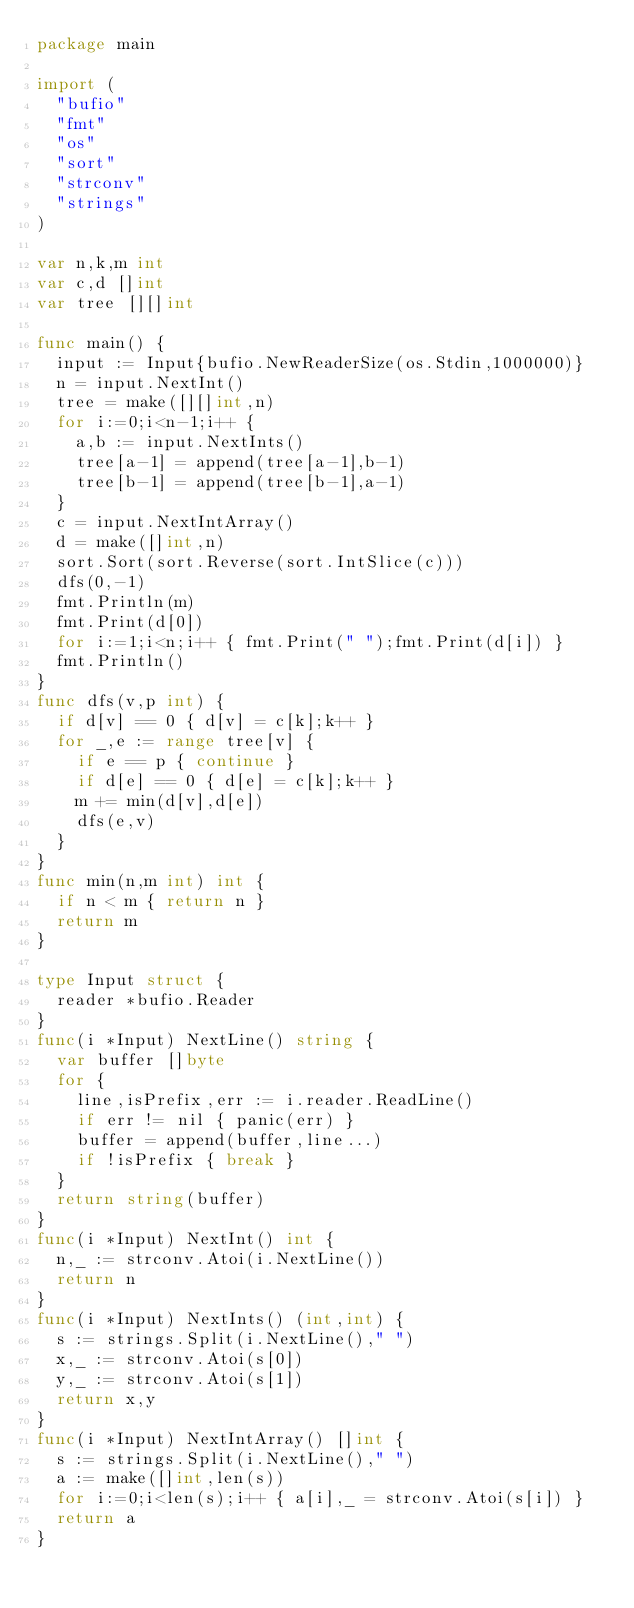<code> <loc_0><loc_0><loc_500><loc_500><_Go_>package main

import (
  "bufio"
  "fmt"
  "os"
  "sort"
  "strconv"
  "strings"
)

var n,k,m int
var c,d []int
var tree [][]int

func main() {
  input := Input{bufio.NewReaderSize(os.Stdin,1000000)}
  n = input.NextInt()
  tree = make([][]int,n)
  for i:=0;i<n-1;i++ {
    a,b := input.NextInts()
    tree[a-1] = append(tree[a-1],b-1)
    tree[b-1] = append(tree[b-1],a-1)
  }
  c = input.NextIntArray()
  d = make([]int,n)
  sort.Sort(sort.Reverse(sort.IntSlice(c)))
  dfs(0,-1)
  fmt.Println(m)
  fmt.Print(d[0])
  for i:=1;i<n;i++ { fmt.Print(" ");fmt.Print(d[i]) }
  fmt.Println()
}
func dfs(v,p int) {
  if d[v] == 0 { d[v] = c[k];k++ }
  for _,e := range tree[v] {
    if e == p { continue }
    if d[e] == 0 { d[e] = c[k];k++ }
    m += min(d[v],d[e])
    dfs(e,v)
  }
}
func min(n,m int) int {
  if n < m { return n }
  return m
}

type Input struct {
  reader *bufio.Reader
}
func(i *Input) NextLine() string {
  var buffer []byte
  for {
    line,isPrefix,err := i.reader.ReadLine()
    if err != nil { panic(err) }
    buffer = append(buffer,line...)
    if !isPrefix { break }
  }
  return string(buffer)
}
func(i *Input) NextInt() int {
  n,_ := strconv.Atoi(i.NextLine())
  return n
}
func(i *Input) NextInts() (int,int) {
  s := strings.Split(i.NextLine()," ")
  x,_ := strconv.Atoi(s[0])
  y,_ := strconv.Atoi(s[1])
  return x,y
}
func(i *Input) NextIntArray() []int {
  s := strings.Split(i.NextLine()," ")
  a := make([]int,len(s))
  for i:=0;i<len(s);i++ { a[i],_ = strconv.Atoi(s[i]) }
  return a
}</code> 